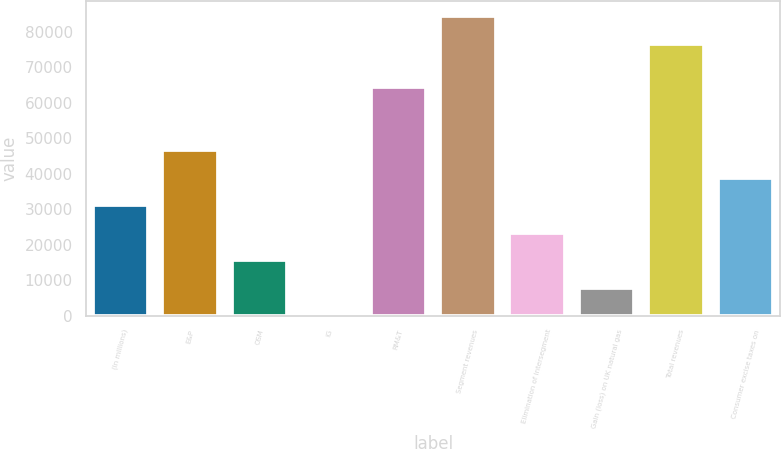Convert chart. <chart><loc_0><loc_0><loc_500><loc_500><bar_chart><fcel>(In millions)<fcel>E&P<fcel>OSM<fcel>IG<fcel>RM&T<fcel>Segment revenues<fcel>Elimination of intersegment<fcel>Gain (loss) on UK natural gas<fcel>Total revenues<fcel>Consumer excise taxes on<nl><fcel>31153<fcel>46683<fcel>15623<fcel>93<fcel>64481<fcel>84519<fcel>23388<fcel>7858<fcel>76754<fcel>38918<nl></chart> 